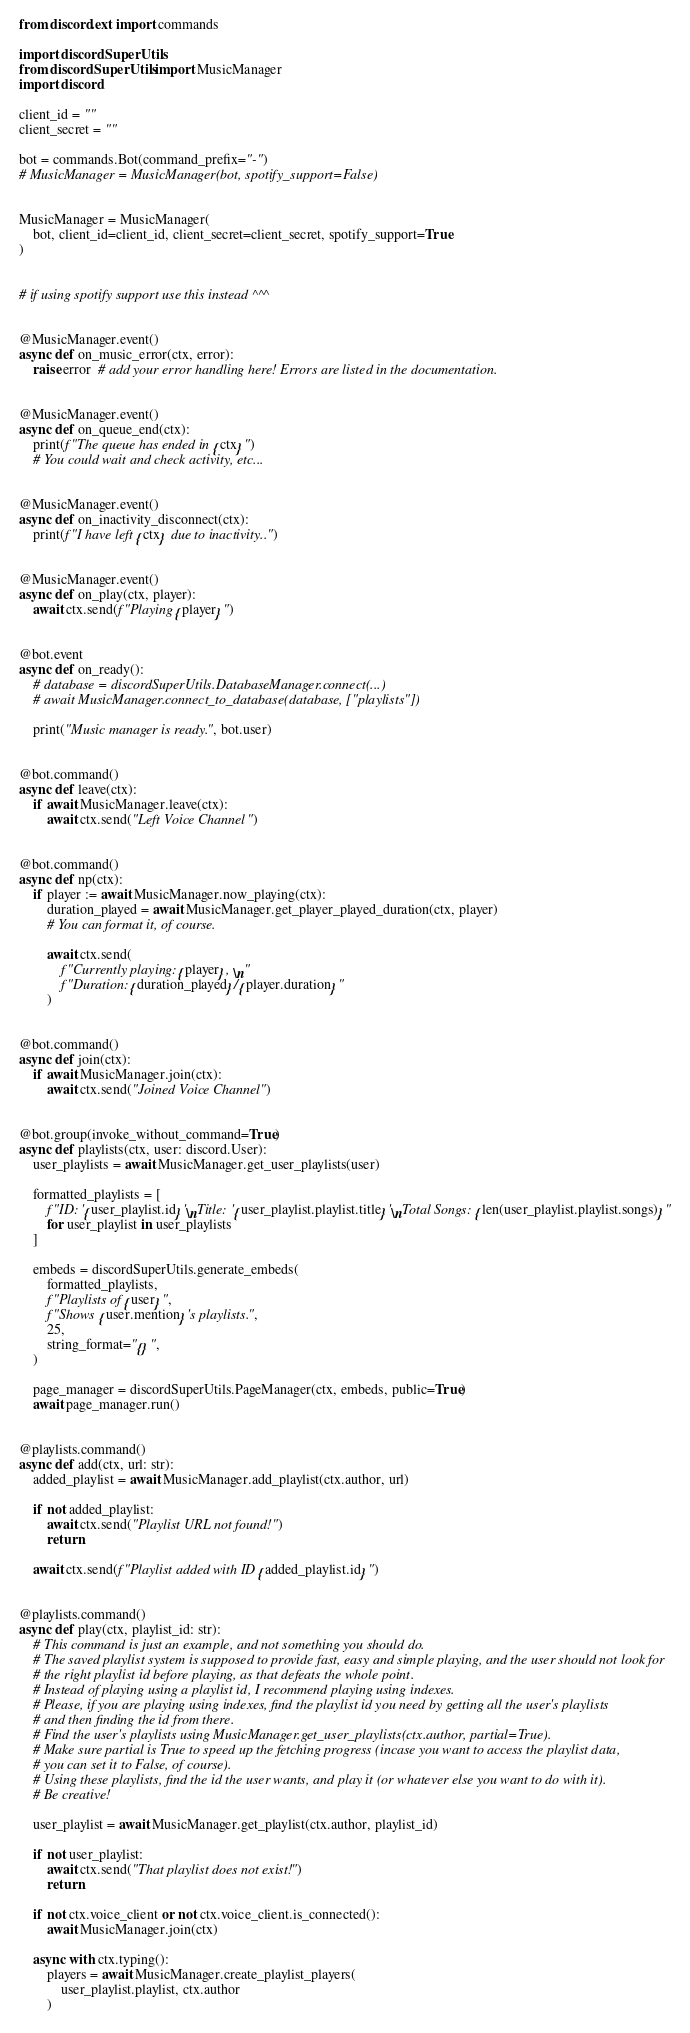<code> <loc_0><loc_0><loc_500><loc_500><_Python_>from discord.ext import commands

import discordSuperUtils
from discordSuperUtils import MusicManager
import discord

client_id = ""
client_secret = ""

bot = commands.Bot(command_prefix="-")
# MusicManager = MusicManager(bot, spotify_support=False)


MusicManager = MusicManager(
    bot, client_id=client_id, client_secret=client_secret, spotify_support=True
)


# if using spotify support use this instead ^^^


@MusicManager.event()
async def on_music_error(ctx, error):
    raise error  # add your error handling here! Errors are listed in the documentation.


@MusicManager.event()
async def on_queue_end(ctx):
    print(f"The queue has ended in {ctx}")
    # You could wait and check activity, etc...


@MusicManager.event()
async def on_inactivity_disconnect(ctx):
    print(f"I have left {ctx} due to inactivity..")


@MusicManager.event()
async def on_play(ctx, player):
    await ctx.send(f"Playing {player}")


@bot.event
async def on_ready():
    # database = discordSuperUtils.DatabaseManager.connect(...)
    # await MusicManager.connect_to_database(database, ["playlists"])

    print("Music manager is ready.", bot.user)


@bot.command()
async def leave(ctx):
    if await MusicManager.leave(ctx):
        await ctx.send("Left Voice Channel")


@bot.command()
async def np(ctx):
    if player := await MusicManager.now_playing(ctx):
        duration_played = await MusicManager.get_player_played_duration(ctx, player)
        # You can format it, of course.

        await ctx.send(
            f"Currently playing: {player}, \n"
            f"Duration: {duration_played}/{player.duration}"
        )


@bot.command()
async def join(ctx):
    if await MusicManager.join(ctx):
        await ctx.send("Joined Voice Channel")


@bot.group(invoke_without_command=True)
async def playlists(ctx, user: discord.User):
    user_playlists = await MusicManager.get_user_playlists(user)

    formatted_playlists = [
        f"ID: '{user_playlist.id}'\nTitle: '{user_playlist.playlist.title}'\nTotal Songs: {len(user_playlist.playlist.songs)}"
        for user_playlist in user_playlists
    ]

    embeds = discordSuperUtils.generate_embeds(
        formatted_playlists,
        f"Playlists of {user}",
        f"Shows {user.mention}'s playlists.",
        25,
        string_format="{}",
    )

    page_manager = discordSuperUtils.PageManager(ctx, embeds, public=True)
    await page_manager.run()


@playlists.command()
async def add(ctx, url: str):
    added_playlist = await MusicManager.add_playlist(ctx.author, url)

    if not added_playlist:
        await ctx.send("Playlist URL not found!")
        return

    await ctx.send(f"Playlist added with ID {added_playlist.id}")


@playlists.command()
async def play(ctx, playlist_id: str):
    # This command is just an example, and not something you should do.
    # The saved playlist system is supposed to provide fast, easy and simple playing, and the user should not look for
    # the right playlist id before playing, as that defeats the whole point.
    # Instead of playing using a playlist id, I recommend playing using indexes.
    # Please, if you are playing using indexes, find the playlist id you need by getting all the user's playlists
    # and then finding the id from there.
    # Find the user's playlists using MusicManager.get_user_playlists(ctx.author, partial=True).
    # Make sure partial is True to speed up the fetching progress (incase you want to access the playlist data,
    # you can set it to False, of course).
    # Using these playlists, find the id the user wants, and play it (or whatever else you want to do with it).
    # Be creative!

    user_playlist = await MusicManager.get_playlist(ctx.author, playlist_id)

    if not user_playlist:
        await ctx.send("That playlist does not exist!")
        return

    if not ctx.voice_client or not ctx.voice_client.is_connected():
        await MusicManager.join(ctx)

    async with ctx.typing():
        players = await MusicManager.create_playlist_players(
            user_playlist.playlist, ctx.author
        )
</code> 